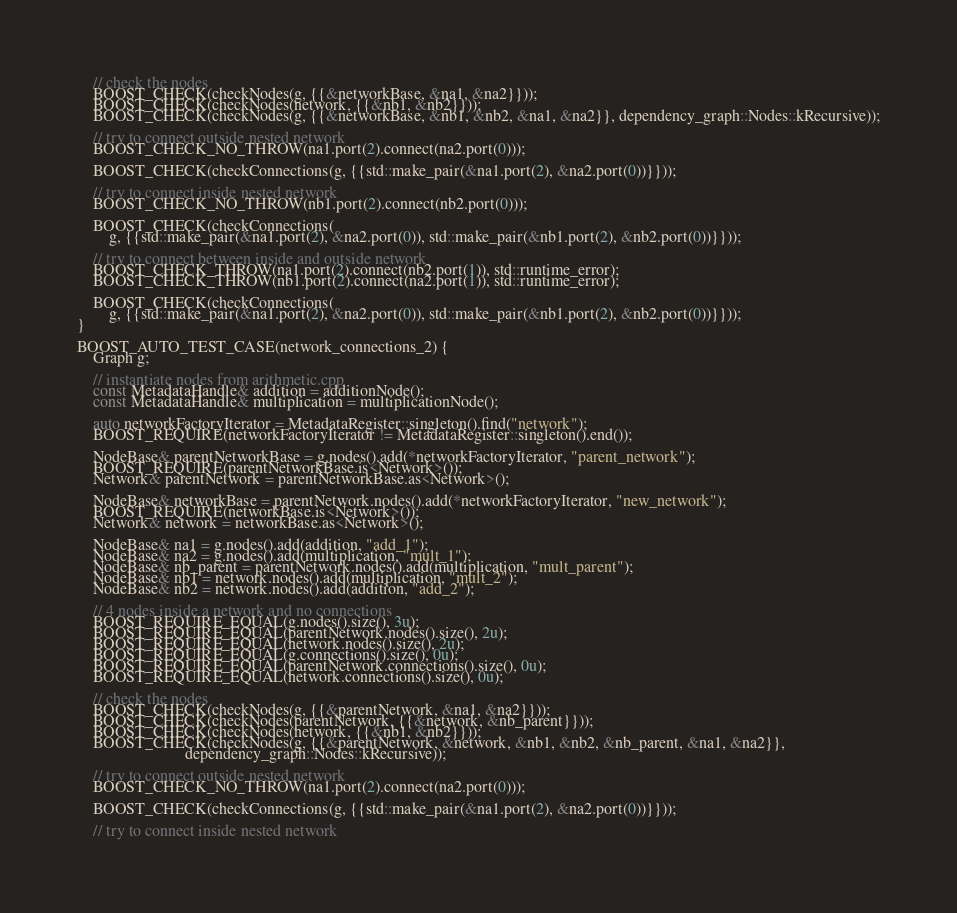Convert code to text. <code><loc_0><loc_0><loc_500><loc_500><_C++_>	// check the nodes
	BOOST_CHECK(checkNodes(g, {{&networkBase, &na1, &na2}}));
	BOOST_CHECK(checkNodes(network, {{&nb1, &nb2}}));
	BOOST_CHECK(checkNodes(g, {{&networkBase, &nb1, &nb2, &na1, &na2}}, dependency_graph::Nodes::kRecursive));

	// try to connect outside nested network
	BOOST_CHECK_NO_THROW(na1.port(2).connect(na2.port(0)));

	BOOST_CHECK(checkConnections(g, {{std::make_pair(&na1.port(2), &na2.port(0))}}));

	// try to connect inside nested network
	BOOST_CHECK_NO_THROW(nb1.port(2).connect(nb2.port(0)));

	BOOST_CHECK(checkConnections(
	    g, {{std::make_pair(&na1.port(2), &na2.port(0)), std::make_pair(&nb1.port(2), &nb2.port(0))}}));

	// try to connect between inside and outside network
	BOOST_CHECK_THROW(na1.port(2).connect(nb2.port(1)), std::runtime_error);
	BOOST_CHECK_THROW(nb1.port(2).connect(na2.port(1)), std::runtime_error);

	BOOST_CHECK(checkConnections(
	    g, {{std::make_pair(&na1.port(2), &na2.port(0)), std::make_pair(&nb1.port(2), &nb2.port(0))}}));
}

BOOST_AUTO_TEST_CASE(network_connections_2) {
	Graph g;

	// instantiate nodes from arithmetic.cpp
	const MetadataHandle& addition = additionNode();
	const MetadataHandle& multiplication = multiplicationNode();

	auto networkFactoryIterator = MetadataRegister::singleton().find("network");
	BOOST_REQUIRE(networkFactoryIterator != MetadataRegister::singleton().end());

	NodeBase& parentNetworkBase = g.nodes().add(*networkFactoryIterator, "parent_network");
	BOOST_REQUIRE(parentNetworkBase.is<Network>());
	Network& parentNetwork = parentNetworkBase.as<Network>();

	NodeBase& networkBase = parentNetwork.nodes().add(*networkFactoryIterator, "new_network");
	BOOST_REQUIRE(networkBase.is<Network>());
	Network& network = networkBase.as<Network>();

	NodeBase& na1 = g.nodes().add(addition, "add_1");
	NodeBase& na2 = g.nodes().add(multiplication, "mult_1");
	NodeBase& nb_parent = parentNetwork.nodes().add(multiplication, "mult_parent");
	NodeBase& nb1 = network.nodes().add(multiplication, "mult_2");
	NodeBase& nb2 = network.nodes().add(addition, "add_2");

	// 4 nodes inside a network and no connections
	BOOST_REQUIRE_EQUAL(g.nodes().size(), 3u);
	BOOST_REQUIRE_EQUAL(parentNetwork.nodes().size(), 2u);
	BOOST_REQUIRE_EQUAL(network.nodes().size(), 2u);
	BOOST_REQUIRE_EQUAL(g.connections().size(), 0u);
	BOOST_REQUIRE_EQUAL(parentNetwork.connections().size(), 0u);
	BOOST_REQUIRE_EQUAL(network.connections().size(), 0u);

	// check the nodes
	BOOST_CHECK(checkNodes(g, {{&parentNetwork, &na1, &na2}}));
	BOOST_CHECK(checkNodes(parentNetwork, {{&network, &nb_parent}}));
	BOOST_CHECK(checkNodes(network, {{&nb1, &nb2}}));
	BOOST_CHECK(checkNodes(g, {{&parentNetwork, &network, &nb1, &nb2, &nb_parent, &na1, &na2}},
	                       dependency_graph::Nodes::kRecursive));

	// try to connect outside nested network
	BOOST_CHECK_NO_THROW(na1.port(2).connect(na2.port(0)));

	BOOST_CHECK(checkConnections(g, {{std::make_pair(&na1.port(2), &na2.port(0))}}));

	// try to connect inside nested network</code> 